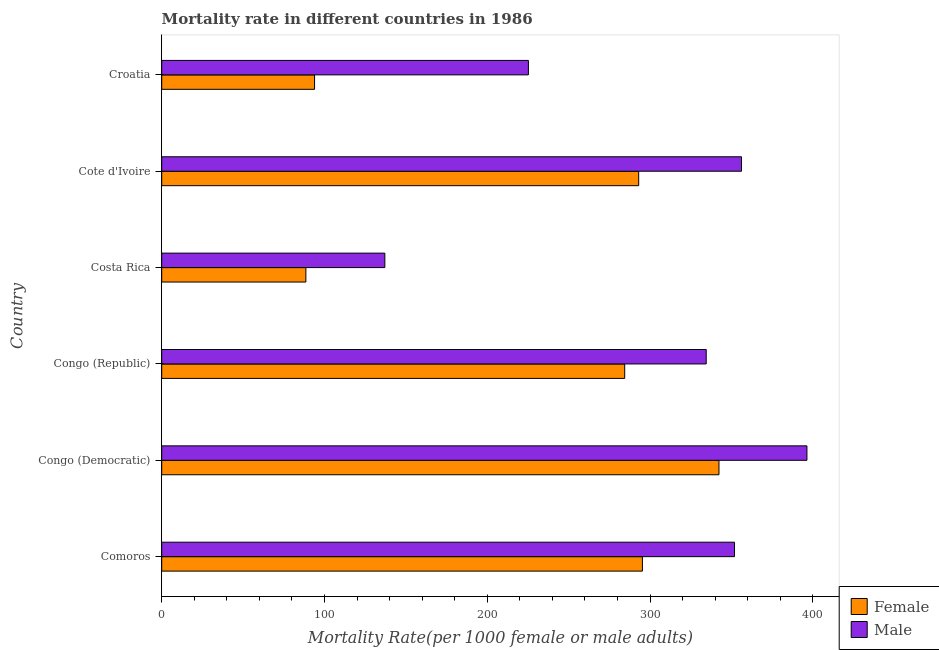How many different coloured bars are there?
Offer a very short reply. 2. Are the number of bars per tick equal to the number of legend labels?
Your response must be concise. Yes. Are the number of bars on each tick of the Y-axis equal?
Offer a terse response. Yes. How many bars are there on the 5th tick from the top?
Provide a short and direct response. 2. What is the female mortality rate in Costa Rica?
Make the answer very short. 88.56. Across all countries, what is the maximum female mortality rate?
Make the answer very short. 342.35. Across all countries, what is the minimum male mortality rate?
Ensure brevity in your answer.  137.08. In which country was the male mortality rate maximum?
Offer a very short reply. Congo (Democratic). In which country was the male mortality rate minimum?
Offer a terse response. Costa Rica. What is the total female mortality rate in the graph?
Offer a terse response. 1397.6. What is the difference between the female mortality rate in Cote d'Ivoire and that in Croatia?
Offer a terse response. 199.12. What is the difference between the male mortality rate in Costa Rica and the female mortality rate in Croatia?
Make the answer very short. 43.17. What is the average female mortality rate per country?
Your answer should be compact. 232.93. What is the difference between the male mortality rate and female mortality rate in Congo (Republic)?
Your response must be concise. 50.08. What is the ratio of the male mortality rate in Congo (Democratic) to that in Congo (Republic)?
Offer a terse response. 1.19. Is the difference between the male mortality rate in Congo (Democratic) and Croatia greater than the difference between the female mortality rate in Congo (Democratic) and Croatia?
Offer a terse response. No. What is the difference between the highest and the second highest male mortality rate?
Provide a short and direct response. 40.21. What is the difference between the highest and the lowest male mortality rate?
Give a very brief answer. 259.31. In how many countries, is the male mortality rate greater than the average male mortality rate taken over all countries?
Provide a succinct answer. 4. How many countries are there in the graph?
Keep it short and to the point. 6. What is the difference between two consecutive major ticks on the X-axis?
Your response must be concise. 100. Does the graph contain any zero values?
Offer a terse response. No. Does the graph contain grids?
Ensure brevity in your answer.  No. How are the legend labels stacked?
Your answer should be compact. Vertical. What is the title of the graph?
Give a very brief answer. Mortality rate in different countries in 1986. Does "Malaria" appear as one of the legend labels in the graph?
Give a very brief answer. No. What is the label or title of the X-axis?
Make the answer very short. Mortality Rate(per 1000 female or male adults). What is the label or title of the Y-axis?
Provide a short and direct response. Country. What is the Mortality Rate(per 1000 female or male adults) in Female in Comoros?
Offer a very short reply. 295.32. What is the Mortality Rate(per 1000 female or male adults) in Male in Comoros?
Keep it short and to the point. 351.9. What is the Mortality Rate(per 1000 female or male adults) in Female in Congo (Democratic)?
Make the answer very short. 342.35. What is the Mortality Rate(per 1000 female or male adults) in Male in Congo (Democratic)?
Offer a terse response. 396.38. What is the Mortality Rate(per 1000 female or male adults) in Female in Congo (Republic)?
Provide a succinct answer. 284.44. What is the Mortality Rate(per 1000 female or male adults) in Male in Congo (Republic)?
Give a very brief answer. 334.51. What is the Mortality Rate(per 1000 female or male adults) in Female in Costa Rica?
Keep it short and to the point. 88.56. What is the Mortality Rate(per 1000 female or male adults) of Male in Costa Rica?
Offer a very short reply. 137.08. What is the Mortality Rate(per 1000 female or male adults) of Female in Cote d'Ivoire?
Ensure brevity in your answer.  293.03. What is the Mortality Rate(per 1000 female or male adults) of Male in Cote d'Ivoire?
Offer a very short reply. 356.18. What is the Mortality Rate(per 1000 female or male adults) in Female in Croatia?
Ensure brevity in your answer.  93.9. What is the Mortality Rate(per 1000 female or male adults) of Male in Croatia?
Give a very brief answer. 225.27. Across all countries, what is the maximum Mortality Rate(per 1000 female or male adults) in Female?
Provide a succinct answer. 342.35. Across all countries, what is the maximum Mortality Rate(per 1000 female or male adults) in Male?
Your response must be concise. 396.38. Across all countries, what is the minimum Mortality Rate(per 1000 female or male adults) of Female?
Make the answer very short. 88.56. Across all countries, what is the minimum Mortality Rate(per 1000 female or male adults) in Male?
Offer a terse response. 137.08. What is the total Mortality Rate(per 1000 female or male adults) of Female in the graph?
Your answer should be very brief. 1397.6. What is the total Mortality Rate(per 1000 female or male adults) in Male in the graph?
Make the answer very short. 1801.33. What is the difference between the Mortality Rate(per 1000 female or male adults) in Female in Comoros and that in Congo (Democratic)?
Provide a short and direct response. -47.02. What is the difference between the Mortality Rate(per 1000 female or male adults) in Male in Comoros and that in Congo (Democratic)?
Provide a succinct answer. -44.48. What is the difference between the Mortality Rate(per 1000 female or male adults) in Female in Comoros and that in Congo (Republic)?
Offer a very short reply. 10.89. What is the difference between the Mortality Rate(per 1000 female or male adults) of Male in Comoros and that in Congo (Republic)?
Keep it short and to the point. 17.39. What is the difference between the Mortality Rate(per 1000 female or male adults) in Female in Comoros and that in Costa Rica?
Your response must be concise. 206.76. What is the difference between the Mortality Rate(per 1000 female or male adults) of Male in Comoros and that in Costa Rica?
Offer a very short reply. 214.82. What is the difference between the Mortality Rate(per 1000 female or male adults) of Female in Comoros and that in Cote d'Ivoire?
Give a very brief answer. 2.29. What is the difference between the Mortality Rate(per 1000 female or male adults) in Male in Comoros and that in Cote d'Ivoire?
Provide a short and direct response. -4.28. What is the difference between the Mortality Rate(per 1000 female or male adults) of Female in Comoros and that in Croatia?
Provide a succinct answer. 201.42. What is the difference between the Mortality Rate(per 1000 female or male adults) of Male in Comoros and that in Croatia?
Make the answer very short. 126.63. What is the difference between the Mortality Rate(per 1000 female or male adults) in Female in Congo (Democratic) and that in Congo (Republic)?
Offer a terse response. 57.91. What is the difference between the Mortality Rate(per 1000 female or male adults) in Male in Congo (Democratic) and that in Congo (Republic)?
Make the answer very short. 61.87. What is the difference between the Mortality Rate(per 1000 female or male adults) of Female in Congo (Democratic) and that in Costa Rica?
Your response must be concise. 253.78. What is the difference between the Mortality Rate(per 1000 female or male adults) of Male in Congo (Democratic) and that in Costa Rica?
Offer a very short reply. 259.31. What is the difference between the Mortality Rate(per 1000 female or male adults) of Female in Congo (Democratic) and that in Cote d'Ivoire?
Provide a short and direct response. 49.32. What is the difference between the Mortality Rate(per 1000 female or male adults) in Male in Congo (Democratic) and that in Cote d'Ivoire?
Your response must be concise. 40.21. What is the difference between the Mortality Rate(per 1000 female or male adults) in Female in Congo (Democratic) and that in Croatia?
Ensure brevity in your answer.  248.44. What is the difference between the Mortality Rate(per 1000 female or male adults) in Male in Congo (Democratic) and that in Croatia?
Ensure brevity in your answer.  171.11. What is the difference between the Mortality Rate(per 1000 female or male adults) in Female in Congo (Republic) and that in Costa Rica?
Offer a terse response. 195.87. What is the difference between the Mortality Rate(per 1000 female or male adults) in Male in Congo (Republic) and that in Costa Rica?
Offer a very short reply. 197.44. What is the difference between the Mortality Rate(per 1000 female or male adults) in Female in Congo (Republic) and that in Cote d'Ivoire?
Give a very brief answer. -8.59. What is the difference between the Mortality Rate(per 1000 female or male adults) of Male in Congo (Republic) and that in Cote d'Ivoire?
Make the answer very short. -21.66. What is the difference between the Mortality Rate(per 1000 female or male adults) in Female in Congo (Republic) and that in Croatia?
Your response must be concise. 190.53. What is the difference between the Mortality Rate(per 1000 female or male adults) of Male in Congo (Republic) and that in Croatia?
Keep it short and to the point. 109.24. What is the difference between the Mortality Rate(per 1000 female or male adults) of Female in Costa Rica and that in Cote d'Ivoire?
Offer a terse response. -204.46. What is the difference between the Mortality Rate(per 1000 female or male adults) in Male in Costa Rica and that in Cote d'Ivoire?
Make the answer very short. -219.1. What is the difference between the Mortality Rate(per 1000 female or male adults) of Female in Costa Rica and that in Croatia?
Offer a very short reply. -5.34. What is the difference between the Mortality Rate(per 1000 female or male adults) in Male in Costa Rica and that in Croatia?
Ensure brevity in your answer.  -88.2. What is the difference between the Mortality Rate(per 1000 female or male adults) in Female in Cote d'Ivoire and that in Croatia?
Your answer should be compact. 199.12. What is the difference between the Mortality Rate(per 1000 female or male adults) in Male in Cote d'Ivoire and that in Croatia?
Provide a short and direct response. 130.91. What is the difference between the Mortality Rate(per 1000 female or male adults) in Female in Comoros and the Mortality Rate(per 1000 female or male adults) in Male in Congo (Democratic)?
Give a very brief answer. -101.06. What is the difference between the Mortality Rate(per 1000 female or male adults) in Female in Comoros and the Mortality Rate(per 1000 female or male adults) in Male in Congo (Republic)?
Your response must be concise. -39.19. What is the difference between the Mortality Rate(per 1000 female or male adults) of Female in Comoros and the Mortality Rate(per 1000 female or male adults) of Male in Costa Rica?
Your answer should be very brief. 158.25. What is the difference between the Mortality Rate(per 1000 female or male adults) in Female in Comoros and the Mortality Rate(per 1000 female or male adults) in Male in Cote d'Ivoire?
Give a very brief answer. -60.86. What is the difference between the Mortality Rate(per 1000 female or male adults) of Female in Comoros and the Mortality Rate(per 1000 female or male adults) of Male in Croatia?
Your answer should be very brief. 70.05. What is the difference between the Mortality Rate(per 1000 female or male adults) in Female in Congo (Democratic) and the Mortality Rate(per 1000 female or male adults) in Male in Congo (Republic)?
Offer a terse response. 7.83. What is the difference between the Mortality Rate(per 1000 female or male adults) in Female in Congo (Democratic) and the Mortality Rate(per 1000 female or male adults) in Male in Costa Rica?
Offer a terse response. 205.27. What is the difference between the Mortality Rate(per 1000 female or male adults) in Female in Congo (Democratic) and the Mortality Rate(per 1000 female or male adults) in Male in Cote d'Ivoire?
Keep it short and to the point. -13.83. What is the difference between the Mortality Rate(per 1000 female or male adults) of Female in Congo (Democratic) and the Mortality Rate(per 1000 female or male adults) of Male in Croatia?
Ensure brevity in your answer.  117.07. What is the difference between the Mortality Rate(per 1000 female or male adults) in Female in Congo (Republic) and the Mortality Rate(per 1000 female or male adults) in Male in Costa Rica?
Keep it short and to the point. 147.36. What is the difference between the Mortality Rate(per 1000 female or male adults) of Female in Congo (Republic) and the Mortality Rate(per 1000 female or male adults) of Male in Cote d'Ivoire?
Your answer should be compact. -71.74. What is the difference between the Mortality Rate(per 1000 female or male adults) of Female in Congo (Republic) and the Mortality Rate(per 1000 female or male adults) of Male in Croatia?
Your response must be concise. 59.16. What is the difference between the Mortality Rate(per 1000 female or male adults) of Female in Costa Rica and the Mortality Rate(per 1000 female or male adults) of Male in Cote d'Ivoire?
Give a very brief answer. -267.61. What is the difference between the Mortality Rate(per 1000 female or male adults) in Female in Costa Rica and the Mortality Rate(per 1000 female or male adults) in Male in Croatia?
Offer a terse response. -136.71. What is the difference between the Mortality Rate(per 1000 female or male adults) of Female in Cote d'Ivoire and the Mortality Rate(per 1000 female or male adults) of Male in Croatia?
Your answer should be compact. 67.75. What is the average Mortality Rate(per 1000 female or male adults) in Female per country?
Provide a short and direct response. 232.93. What is the average Mortality Rate(per 1000 female or male adults) of Male per country?
Provide a succinct answer. 300.22. What is the difference between the Mortality Rate(per 1000 female or male adults) of Female and Mortality Rate(per 1000 female or male adults) of Male in Comoros?
Offer a very short reply. -56.58. What is the difference between the Mortality Rate(per 1000 female or male adults) of Female and Mortality Rate(per 1000 female or male adults) of Male in Congo (Democratic)?
Your answer should be compact. -54.04. What is the difference between the Mortality Rate(per 1000 female or male adults) in Female and Mortality Rate(per 1000 female or male adults) in Male in Congo (Republic)?
Give a very brief answer. -50.08. What is the difference between the Mortality Rate(per 1000 female or male adults) in Female and Mortality Rate(per 1000 female or male adults) in Male in Costa Rica?
Ensure brevity in your answer.  -48.51. What is the difference between the Mortality Rate(per 1000 female or male adults) of Female and Mortality Rate(per 1000 female or male adults) of Male in Cote d'Ivoire?
Your response must be concise. -63.15. What is the difference between the Mortality Rate(per 1000 female or male adults) of Female and Mortality Rate(per 1000 female or male adults) of Male in Croatia?
Offer a very short reply. -131.37. What is the ratio of the Mortality Rate(per 1000 female or male adults) of Female in Comoros to that in Congo (Democratic)?
Your answer should be compact. 0.86. What is the ratio of the Mortality Rate(per 1000 female or male adults) of Male in Comoros to that in Congo (Democratic)?
Ensure brevity in your answer.  0.89. What is the ratio of the Mortality Rate(per 1000 female or male adults) of Female in Comoros to that in Congo (Republic)?
Ensure brevity in your answer.  1.04. What is the ratio of the Mortality Rate(per 1000 female or male adults) in Male in Comoros to that in Congo (Republic)?
Offer a terse response. 1.05. What is the ratio of the Mortality Rate(per 1000 female or male adults) in Female in Comoros to that in Costa Rica?
Provide a succinct answer. 3.33. What is the ratio of the Mortality Rate(per 1000 female or male adults) of Male in Comoros to that in Costa Rica?
Offer a very short reply. 2.57. What is the ratio of the Mortality Rate(per 1000 female or male adults) of Male in Comoros to that in Cote d'Ivoire?
Offer a terse response. 0.99. What is the ratio of the Mortality Rate(per 1000 female or male adults) of Female in Comoros to that in Croatia?
Offer a terse response. 3.15. What is the ratio of the Mortality Rate(per 1000 female or male adults) in Male in Comoros to that in Croatia?
Your answer should be compact. 1.56. What is the ratio of the Mortality Rate(per 1000 female or male adults) in Female in Congo (Democratic) to that in Congo (Republic)?
Provide a short and direct response. 1.2. What is the ratio of the Mortality Rate(per 1000 female or male adults) of Male in Congo (Democratic) to that in Congo (Republic)?
Provide a succinct answer. 1.19. What is the ratio of the Mortality Rate(per 1000 female or male adults) in Female in Congo (Democratic) to that in Costa Rica?
Keep it short and to the point. 3.87. What is the ratio of the Mortality Rate(per 1000 female or male adults) in Male in Congo (Democratic) to that in Costa Rica?
Keep it short and to the point. 2.89. What is the ratio of the Mortality Rate(per 1000 female or male adults) of Female in Congo (Democratic) to that in Cote d'Ivoire?
Make the answer very short. 1.17. What is the ratio of the Mortality Rate(per 1000 female or male adults) in Male in Congo (Democratic) to that in Cote d'Ivoire?
Your answer should be compact. 1.11. What is the ratio of the Mortality Rate(per 1000 female or male adults) in Female in Congo (Democratic) to that in Croatia?
Make the answer very short. 3.65. What is the ratio of the Mortality Rate(per 1000 female or male adults) in Male in Congo (Democratic) to that in Croatia?
Make the answer very short. 1.76. What is the ratio of the Mortality Rate(per 1000 female or male adults) in Female in Congo (Republic) to that in Costa Rica?
Offer a terse response. 3.21. What is the ratio of the Mortality Rate(per 1000 female or male adults) of Male in Congo (Republic) to that in Costa Rica?
Ensure brevity in your answer.  2.44. What is the ratio of the Mortality Rate(per 1000 female or male adults) of Female in Congo (Republic) to that in Cote d'Ivoire?
Ensure brevity in your answer.  0.97. What is the ratio of the Mortality Rate(per 1000 female or male adults) of Male in Congo (Republic) to that in Cote d'Ivoire?
Your answer should be very brief. 0.94. What is the ratio of the Mortality Rate(per 1000 female or male adults) of Female in Congo (Republic) to that in Croatia?
Provide a short and direct response. 3.03. What is the ratio of the Mortality Rate(per 1000 female or male adults) in Male in Congo (Republic) to that in Croatia?
Ensure brevity in your answer.  1.48. What is the ratio of the Mortality Rate(per 1000 female or male adults) in Female in Costa Rica to that in Cote d'Ivoire?
Offer a very short reply. 0.3. What is the ratio of the Mortality Rate(per 1000 female or male adults) in Male in Costa Rica to that in Cote d'Ivoire?
Ensure brevity in your answer.  0.38. What is the ratio of the Mortality Rate(per 1000 female or male adults) in Female in Costa Rica to that in Croatia?
Provide a short and direct response. 0.94. What is the ratio of the Mortality Rate(per 1000 female or male adults) of Male in Costa Rica to that in Croatia?
Your answer should be compact. 0.61. What is the ratio of the Mortality Rate(per 1000 female or male adults) of Female in Cote d'Ivoire to that in Croatia?
Offer a very short reply. 3.12. What is the ratio of the Mortality Rate(per 1000 female or male adults) of Male in Cote d'Ivoire to that in Croatia?
Offer a terse response. 1.58. What is the difference between the highest and the second highest Mortality Rate(per 1000 female or male adults) in Female?
Offer a terse response. 47.02. What is the difference between the highest and the second highest Mortality Rate(per 1000 female or male adults) of Male?
Offer a terse response. 40.21. What is the difference between the highest and the lowest Mortality Rate(per 1000 female or male adults) in Female?
Provide a succinct answer. 253.78. What is the difference between the highest and the lowest Mortality Rate(per 1000 female or male adults) in Male?
Provide a short and direct response. 259.31. 